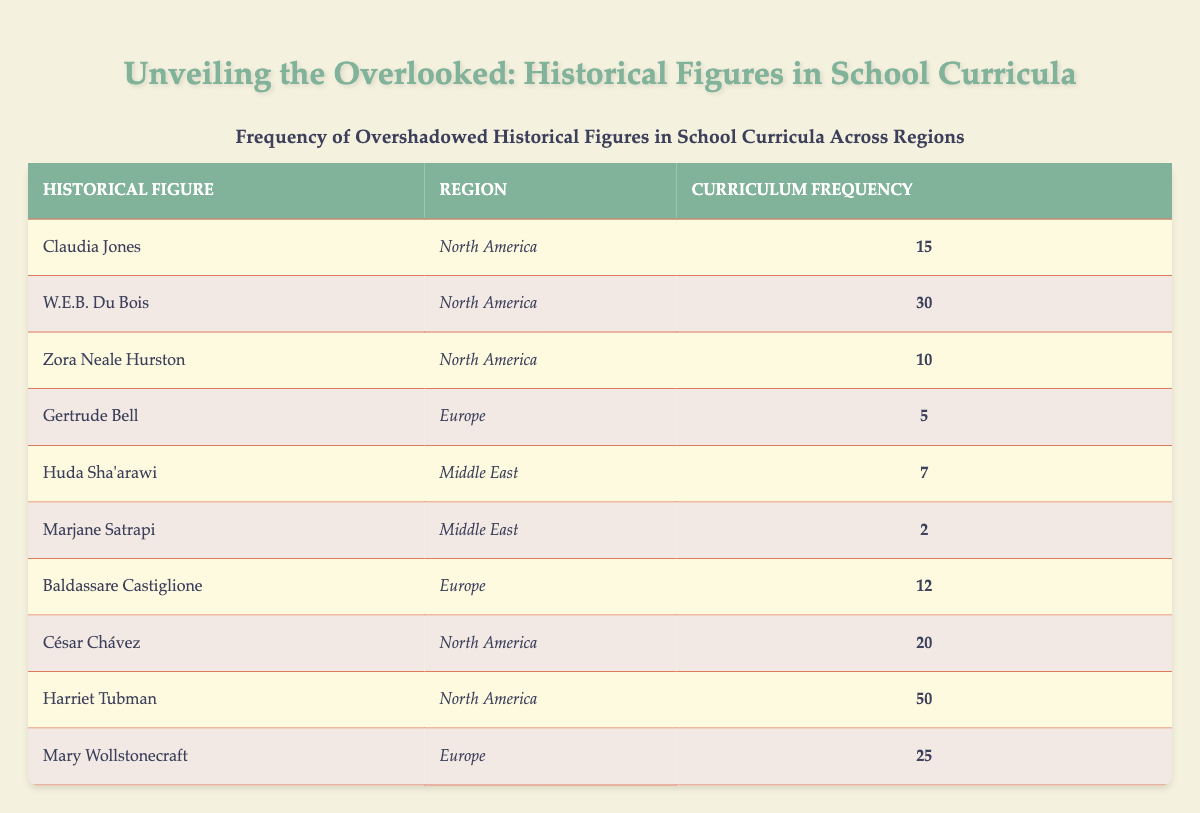What is the highest curriculum frequency in North America? The figures listed under North America are Claudia Jones (15), W.E.B. Du Bois (30), Zora Neale Hurston (10), César Chávez (20), and Harriet Tubman (50). Among these, Harriet Tubman has the highest frequency of 50.
Answer: 50 How many historical figures from Europe are mentioned in the table? The historical figures from Europe listed are Gertrude Bell (5), Baldassare Castiglione (12), and Mary Wollstonecraft (25). This totals to 3 figures mentioned from Europe.
Answer: 3 What is the total curriculum frequency for historical figures in the Middle East? The figures for the Middle East are Huda Sha'arawi (7) and Marjane Satrapi (2). Adding these gives a total of 7 + 2 = 9 for the Middle East.
Answer: 9 Is Zora Neale Hurston mentioned more frequently than Gertrude Bell? Zora Neale Hurston has a frequency of 10, while Gertrude Bell has a frequency of 5. Since 10 is greater than 5, the statement is true.
Answer: Yes What is the average curriculum frequency of the historical figures in Europe? The frequencies for Europe are Gertrude Bell (5), Baldassare Castiglione (12), and Mary Wollstonecraft (25). First, sum them up: 5 + 12 + 25 = 42. Then, divide by the number of figures (3): 42 / 3 = 14. Therefore, the average is 14.
Answer: 14 Which region has the lowest total frequency of historical figures, and what is that total? The Middle East has two figures, with a total frequency of 9 (Huda Sha'arawi 7 + Marjane Satrapi 2). In comparison, Europe has 42 and North America has 115 (adding all figures in that region). Thus, the Middle East has the lowest total frequency of 9.
Answer: 9 What is the difference in frequency between the most and least mentioned historical figures in the table? The most mentioned figure is Harriet Tubman at 50, and the least mentioned figure is Marjane Satrapi at 2. The difference is calculated as 50 - 2 = 48.
Answer: 48 How many historical figures have a curriculum frequency of 10 or lower? The figures with frequencies at or below 10 are Zora Neale Hurston (10), Gertrude Bell (5), Huda Sha'arawi (7), and Marjane Satrapi (2). That gives us a total of 4 figures.
Answer: 4 Which historical figure from North America has the second highest curriculum frequency? In North America, the figures and their frequencies are Harriet Tubman (50), W.E.B. Du Bois (30), César Chávez (20), Claudia Jones (15), and Zora Neale Hurston (10). The second highest is W.E.B. Du Bois with a frequency of 30.
Answer: W.E.B. Du Bois 